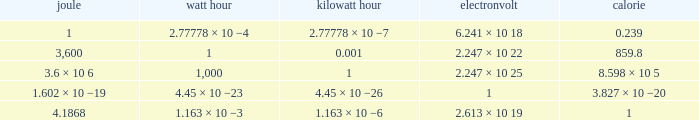How many calories is 1 watt hour? 859.8. 